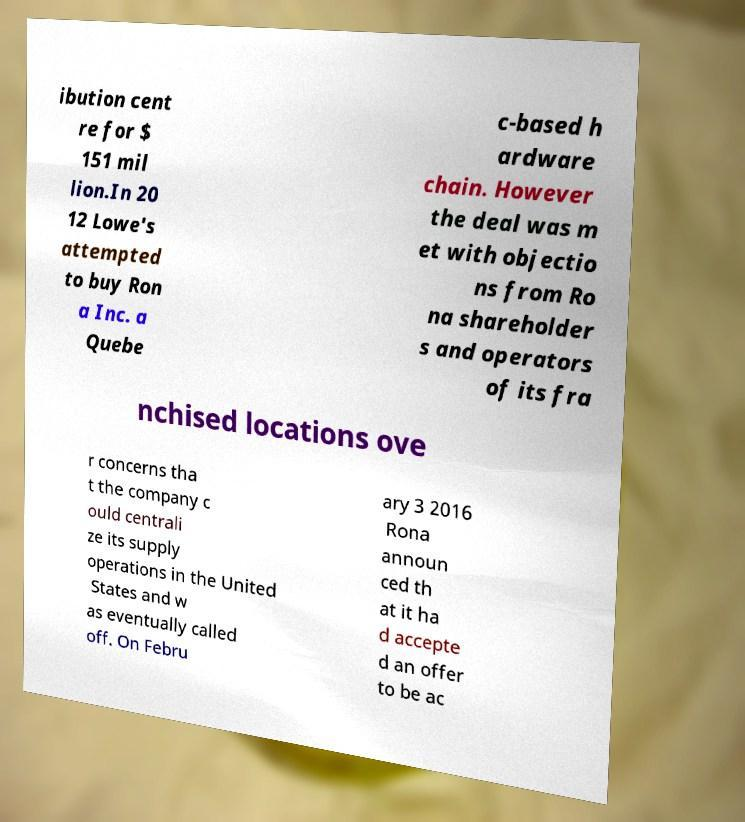Could you extract and type out the text from this image? ibution cent re for $ 151 mil lion.In 20 12 Lowe's attempted to buy Ron a Inc. a Quebe c-based h ardware chain. However the deal was m et with objectio ns from Ro na shareholder s and operators of its fra nchised locations ove r concerns tha t the company c ould centrali ze its supply operations in the United States and w as eventually called off. On Febru ary 3 2016 Rona announ ced th at it ha d accepte d an offer to be ac 